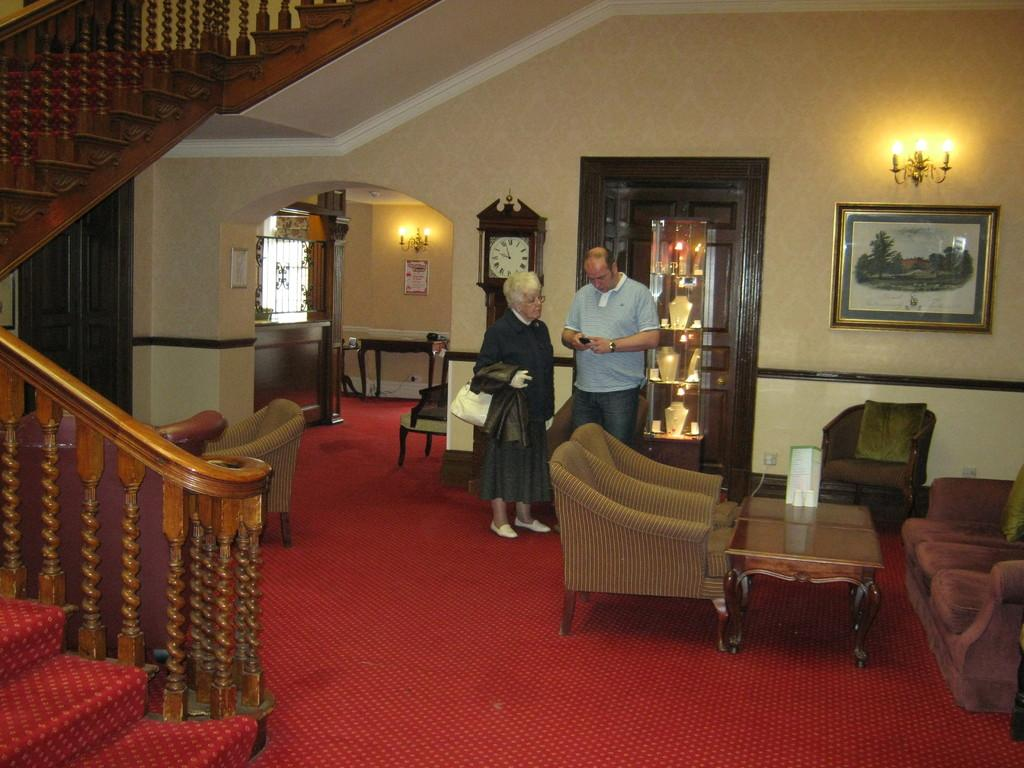Who is present in the image? There is a woman and a man in the image. Where are the woman and man located? They are standing in a building. What feature of the building can be seen in the image? The building has stairs. What type of furniture is visible in the image? There is a sofa in the image. What type of notebook is the woman holding in the image? There is no notebook present in the image. How are the pizzas being transported in the image? There are no pizzas present in the image. 